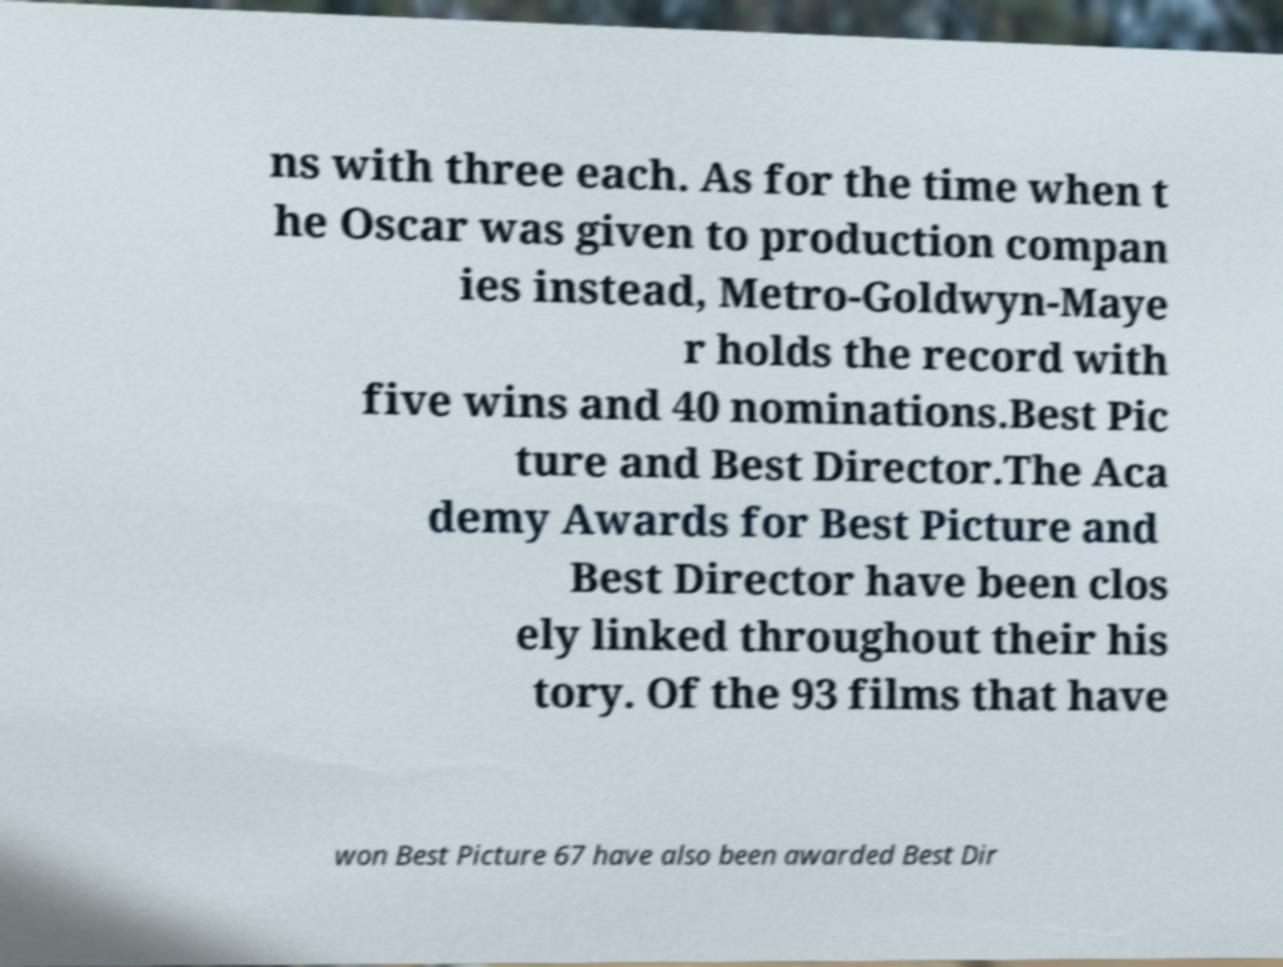Could you assist in decoding the text presented in this image and type it out clearly? ns with three each. As for the time when t he Oscar was given to production compan ies instead, Metro-Goldwyn-Maye r holds the record with five wins and 40 nominations.Best Pic ture and Best Director.The Aca demy Awards for Best Picture and Best Director have been clos ely linked throughout their his tory. Of the 93 films that have won Best Picture 67 have also been awarded Best Dir 